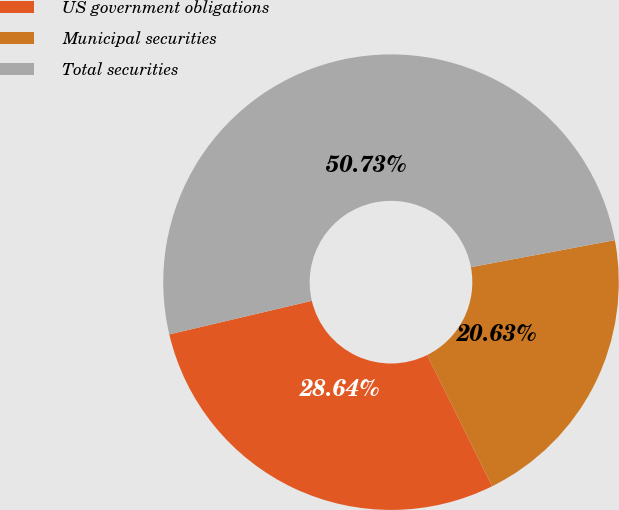Convert chart to OTSL. <chart><loc_0><loc_0><loc_500><loc_500><pie_chart><fcel>US government obligations<fcel>Municipal securities<fcel>Total securities<nl><fcel>28.64%<fcel>20.63%<fcel>50.73%<nl></chart> 